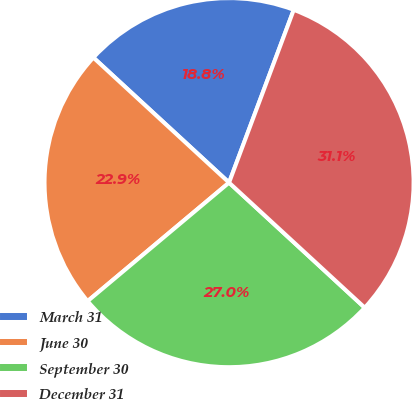Convert chart. <chart><loc_0><loc_0><loc_500><loc_500><pie_chart><fcel>March 31<fcel>June 30<fcel>September 30<fcel>December 31<nl><fcel>18.85%<fcel>22.95%<fcel>27.05%<fcel>31.15%<nl></chart> 